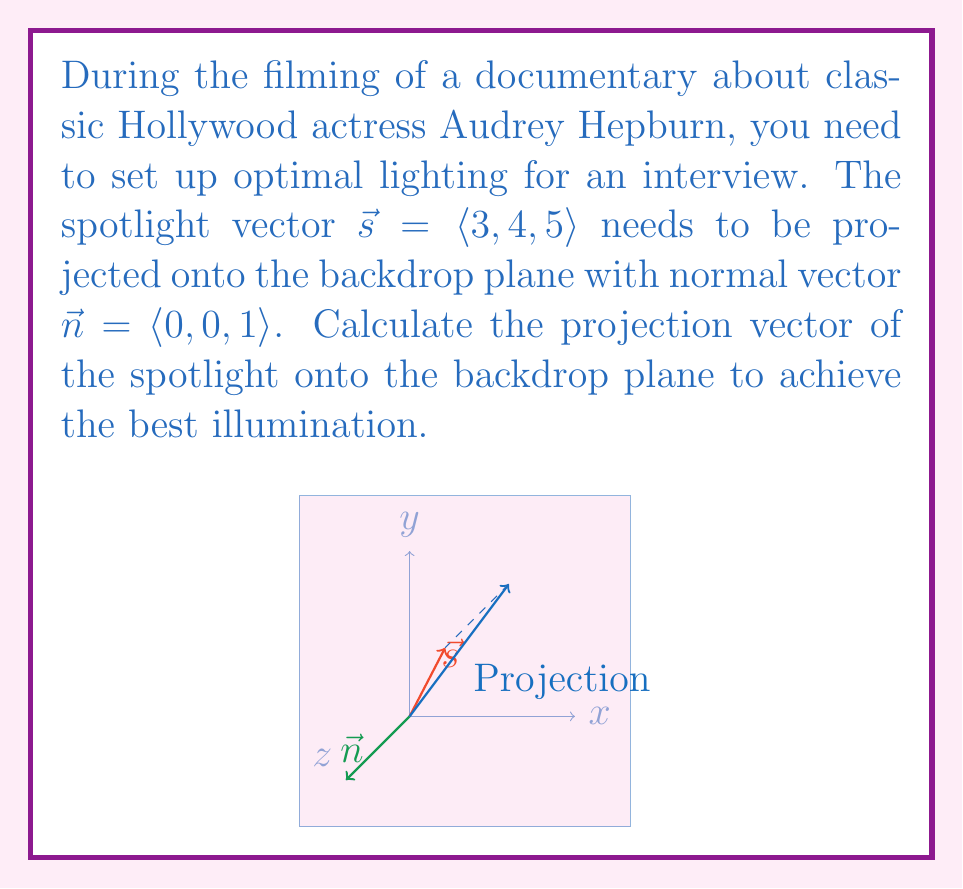Can you answer this question? To find the projection of the spotlight vector $\vec{s}$ onto the backdrop plane, we need to use the vector projection formula and then subtract this from the original vector. The steps are as follows:

1) The formula for vector projection of $\vec{s}$ onto $\vec{n}$ is:

   $$\text{proj}_{\vec{n}}\vec{s} = \frac{\vec{s} \cdot \vec{n}}{\|\vec{n}\|^2} \vec{n}$$

2) Calculate the dot product $\vec{s} \cdot \vec{n}$:
   $$\vec{s} \cdot \vec{n} = 3(0) + 4(0) + 5(1) = 5$$

3) Calculate $\|\vec{n}\|^2$:
   $$\|\vec{n}\|^2 = 0^2 + 0^2 + 1^2 = 1$$

4) Substitute into the projection formula:
   $$\text{proj}_{\vec{n}}\vec{s} = \frac{5}{1} \langle 0, 0, 1 \rangle = \langle 0, 0, 5 \rangle$$

5) The projection onto the plane is the difference between $\vec{s}$ and its projection onto $\vec{n}$:
   $$\vec{s} - \text{proj}_{\vec{n}}\vec{s} = \langle 3, 4, 5 \rangle - \langle 0, 0, 5 \rangle = \langle 3, 4, 0 \rangle$$

This vector $\langle 3, 4, 0 \rangle$ represents the optimal projection of the spotlight onto the backdrop plane for the best illumination of Audrey Hepburn during the interview.
Answer: $\langle 3, 4, 0 \rangle$ 